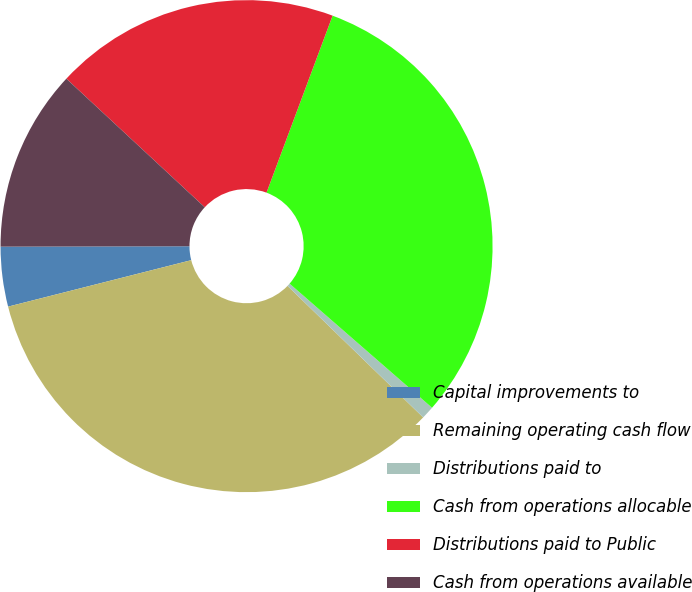Convert chart to OTSL. <chart><loc_0><loc_0><loc_500><loc_500><pie_chart><fcel>Capital improvements to<fcel>Remaining operating cash flow<fcel>Distributions paid to<fcel>Cash from operations allocable<fcel>Distributions paid to Public<fcel>Cash from operations available<nl><fcel>3.92%<fcel>33.79%<fcel>0.85%<fcel>30.72%<fcel>18.77%<fcel>11.95%<nl></chart> 